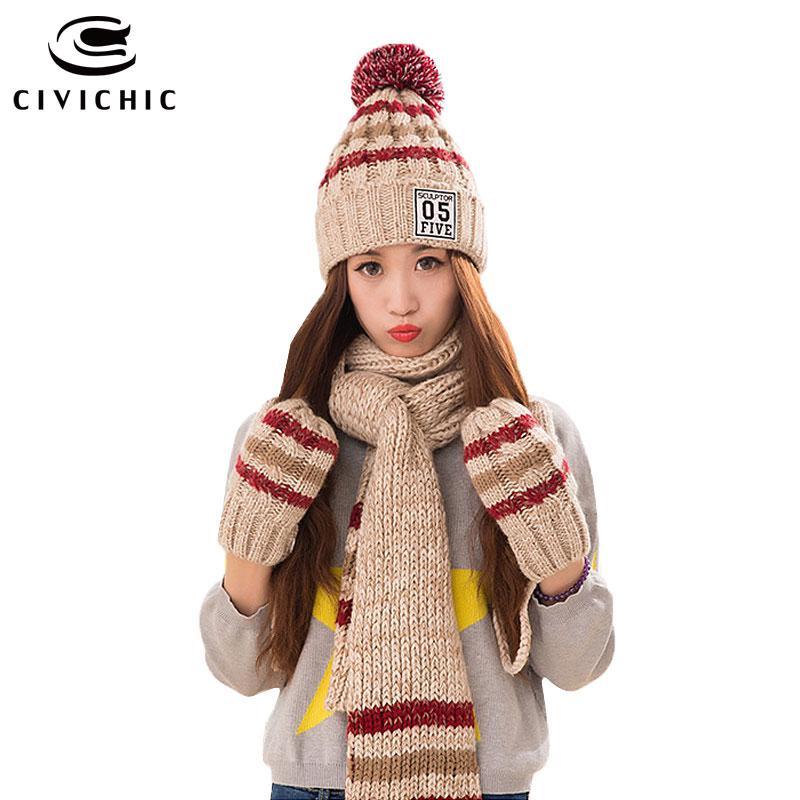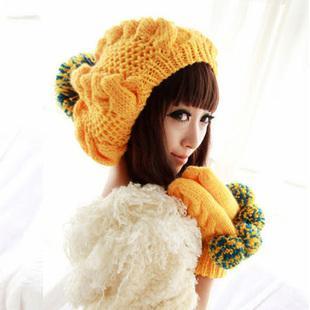The first image is the image on the left, the second image is the image on the right. For the images shown, is this caption "In one image, a girl is wearing matching hat, mittens and scarf, into which a stripe design has been knitted, with one long end of the scarf draped in front of her." true? Answer yes or no. Yes. The first image is the image on the left, the second image is the image on the right. Analyze the images presented: Is the assertion "Both women are wearing hats with pom poms." valid? Answer yes or no. Yes. 